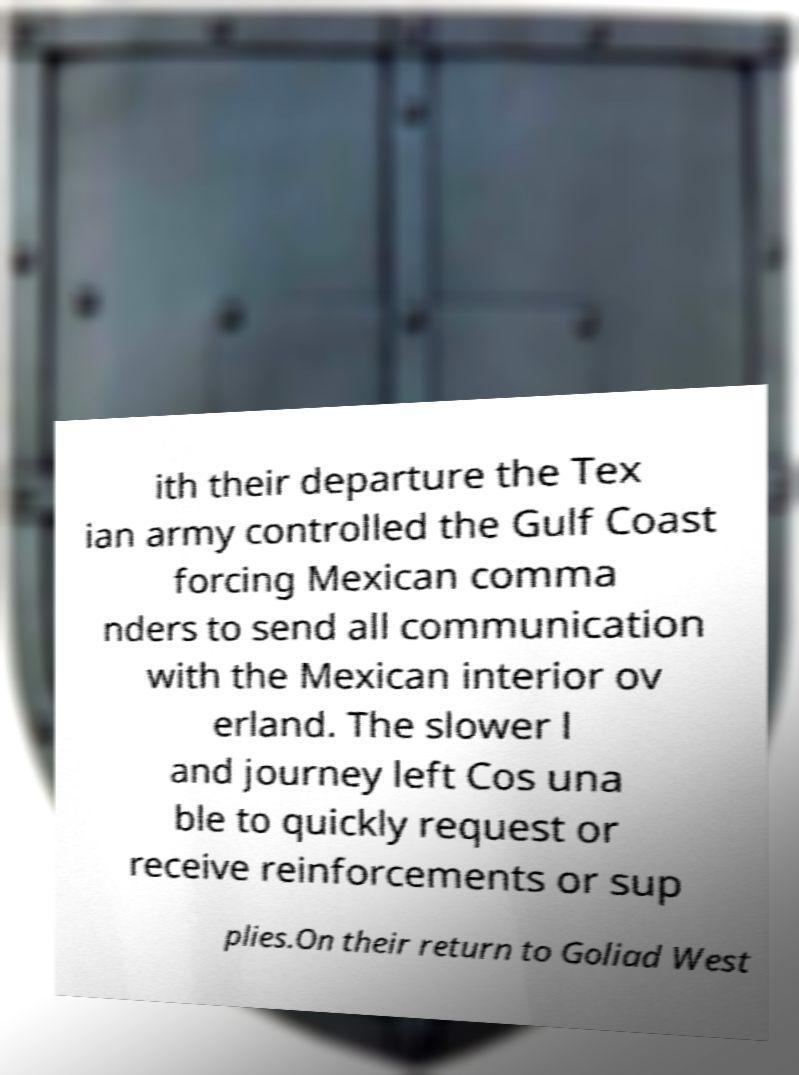For documentation purposes, I need the text within this image transcribed. Could you provide that? ith their departure the Tex ian army controlled the Gulf Coast forcing Mexican comma nders to send all communication with the Mexican interior ov erland. The slower l and journey left Cos una ble to quickly request or receive reinforcements or sup plies.On their return to Goliad West 